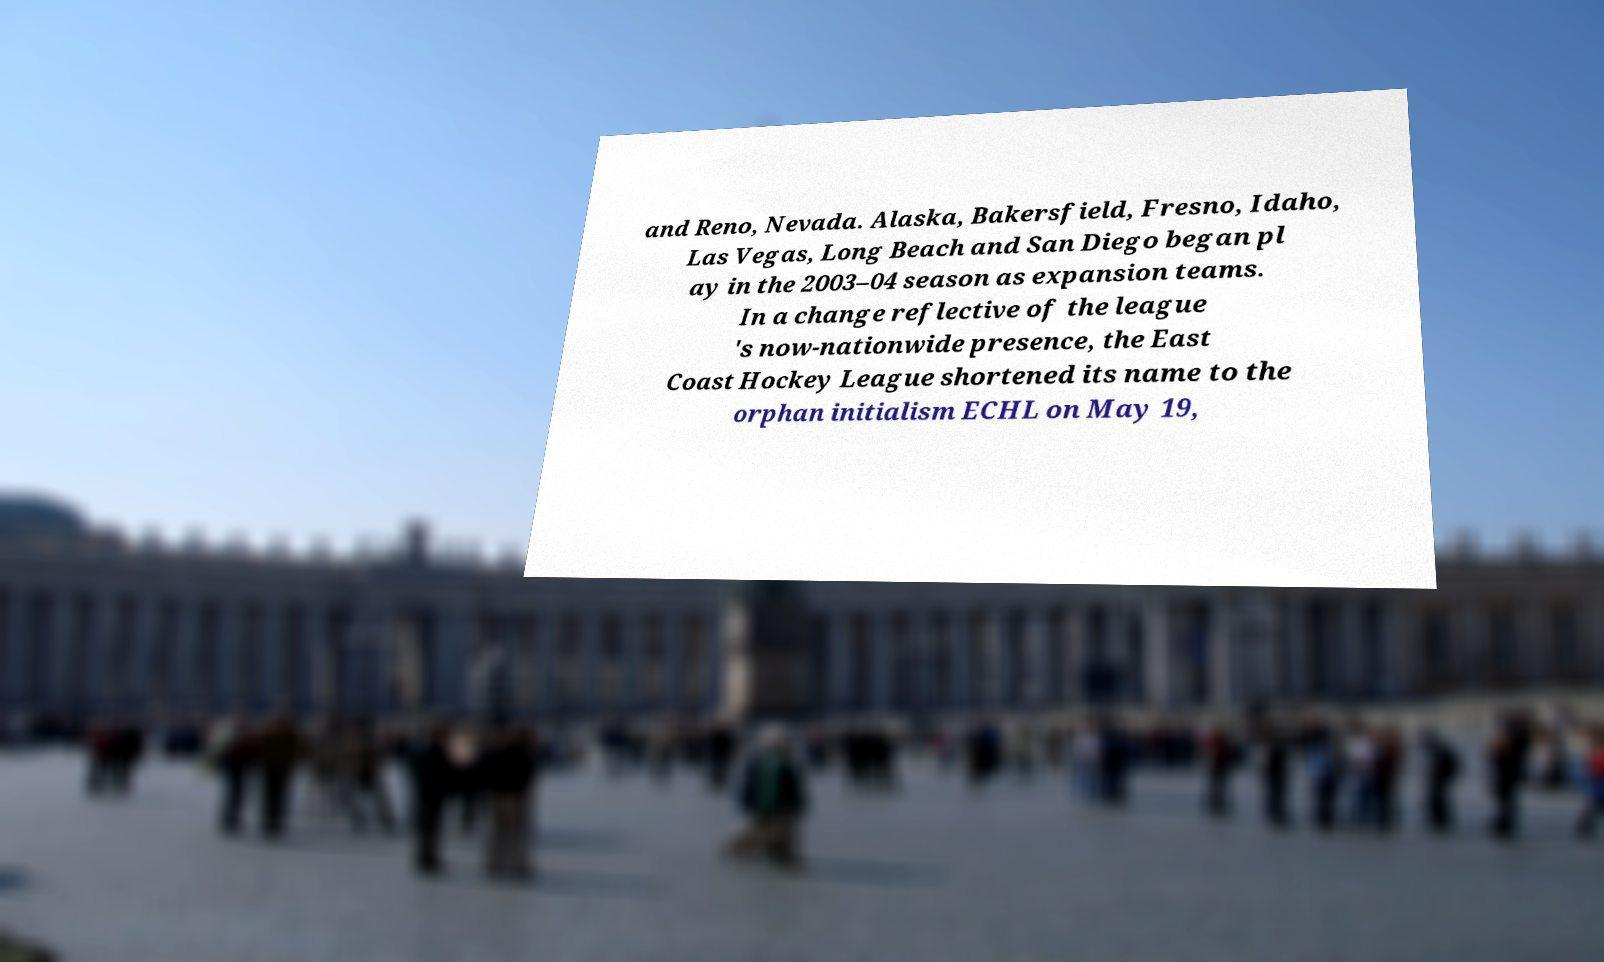Can you accurately transcribe the text from the provided image for me? and Reno, Nevada. Alaska, Bakersfield, Fresno, Idaho, Las Vegas, Long Beach and San Diego began pl ay in the 2003–04 season as expansion teams. In a change reflective of the league 's now-nationwide presence, the East Coast Hockey League shortened its name to the orphan initialism ECHL on May 19, 